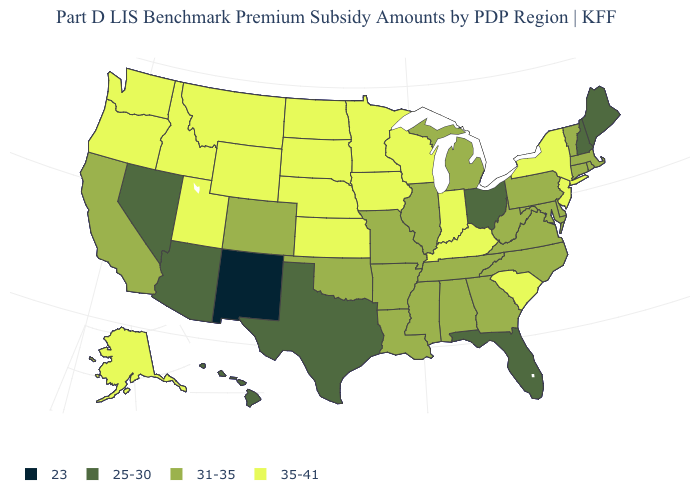Name the states that have a value in the range 23?
Write a very short answer. New Mexico. Name the states that have a value in the range 35-41?
Be succinct. Alaska, Idaho, Indiana, Iowa, Kansas, Kentucky, Minnesota, Montana, Nebraska, New Jersey, New York, North Dakota, Oregon, South Carolina, South Dakota, Utah, Washington, Wisconsin, Wyoming. What is the value of North Carolina?
Quick response, please. 31-35. Which states have the highest value in the USA?
Keep it brief. Alaska, Idaho, Indiana, Iowa, Kansas, Kentucky, Minnesota, Montana, Nebraska, New Jersey, New York, North Dakota, Oregon, South Carolina, South Dakota, Utah, Washington, Wisconsin, Wyoming. What is the value of Wyoming?
Write a very short answer. 35-41. What is the value of Michigan?
Write a very short answer. 31-35. Name the states that have a value in the range 31-35?
Keep it brief. Alabama, Arkansas, California, Colorado, Connecticut, Delaware, Georgia, Illinois, Louisiana, Maryland, Massachusetts, Michigan, Mississippi, Missouri, North Carolina, Oklahoma, Pennsylvania, Rhode Island, Tennessee, Vermont, Virginia, West Virginia. What is the lowest value in the USA?
Keep it brief. 23. Does Iowa have the same value as Alaska?
Concise answer only. Yes. Which states have the lowest value in the USA?
Be succinct. New Mexico. What is the value of Utah?
Quick response, please. 35-41. What is the value of Rhode Island?
Short answer required. 31-35. What is the value of New Hampshire?
Quick response, please. 25-30. Which states have the highest value in the USA?
Write a very short answer. Alaska, Idaho, Indiana, Iowa, Kansas, Kentucky, Minnesota, Montana, Nebraska, New Jersey, New York, North Dakota, Oregon, South Carolina, South Dakota, Utah, Washington, Wisconsin, Wyoming. What is the value of Louisiana?
Write a very short answer. 31-35. 